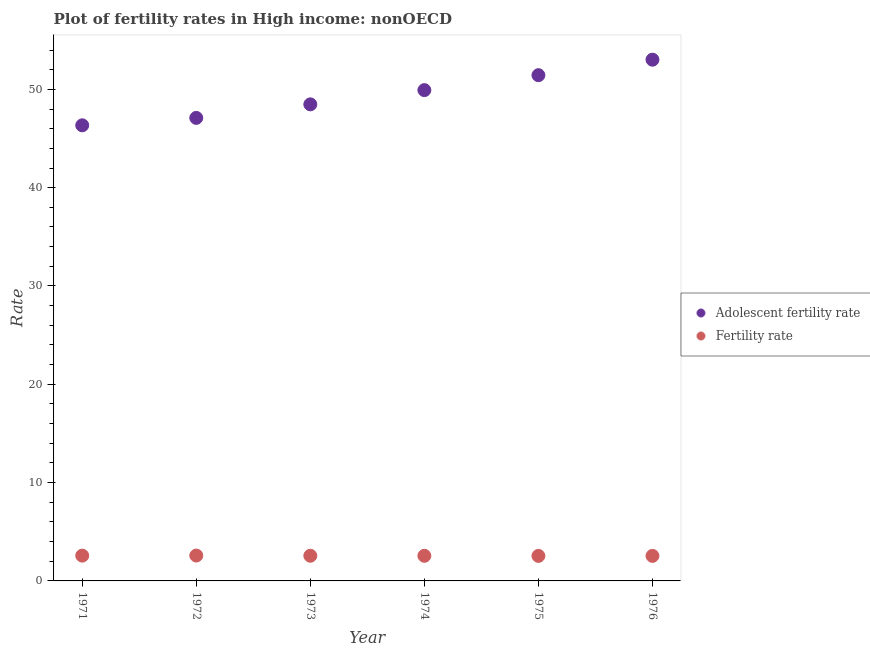What is the adolescent fertility rate in 1976?
Your answer should be compact. 53.02. Across all years, what is the maximum fertility rate?
Give a very brief answer. 2.58. Across all years, what is the minimum adolescent fertility rate?
Ensure brevity in your answer.  46.34. In which year was the adolescent fertility rate minimum?
Keep it short and to the point. 1971. What is the total fertility rate in the graph?
Give a very brief answer. 15.36. What is the difference between the fertility rate in 1972 and that in 1975?
Your response must be concise. 0.04. What is the difference between the adolescent fertility rate in 1972 and the fertility rate in 1971?
Your answer should be very brief. 44.52. What is the average fertility rate per year?
Your response must be concise. 2.56. In the year 1975, what is the difference between the adolescent fertility rate and fertility rate?
Give a very brief answer. 48.9. In how many years, is the adolescent fertility rate greater than 14?
Offer a very short reply. 6. What is the ratio of the adolescent fertility rate in 1974 to that in 1976?
Your answer should be compact. 0.94. Is the difference between the adolescent fertility rate in 1973 and 1976 greater than the difference between the fertility rate in 1973 and 1976?
Provide a short and direct response. No. What is the difference between the highest and the second highest adolescent fertility rate?
Offer a terse response. 1.58. What is the difference between the highest and the lowest adolescent fertility rate?
Your response must be concise. 6.67. Does the fertility rate monotonically increase over the years?
Ensure brevity in your answer.  No. Is the fertility rate strictly less than the adolescent fertility rate over the years?
Provide a short and direct response. Yes. What is the difference between two consecutive major ticks on the Y-axis?
Offer a very short reply. 10. Does the graph contain any zero values?
Give a very brief answer. No. Where does the legend appear in the graph?
Offer a terse response. Center right. What is the title of the graph?
Provide a succinct answer. Plot of fertility rates in High income: nonOECD. Does "Taxes on profits and capital gains" appear as one of the legend labels in the graph?
Your answer should be compact. No. What is the label or title of the X-axis?
Ensure brevity in your answer.  Year. What is the label or title of the Y-axis?
Your answer should be compact. Rate. What is the Rate in Adolescent fertility rate in 1971?
Your answer should be compact. 46.34. What is the Rate in Fertility rate in 1971?
Give a very brief answer. 2.57. What is the Rate in Adolescent fertility rate in 1972?
Keep it short and to the point. 47.1. What is the Rate of Fertility rate in 1972?
Provide a succinct answer. 2.58. What is the Rate of Adolescent fertility rate in 1973?
Your response must be concise. 48.47. What is the Rate of Fertility rate in 1973?
Your response must be concise. 2.56. What is the Rate in Adolescent fertility rate in 1974?
Give a very brief answer. 49.92. What is the Rate in Fertility rate in 1974?
Provide a short and direct response. 2.55. What is the Rate of Adolescent fertility rate in 1975?
Your answer should be very brief. 51.44. What is the Rate in Fertility rate in 1975?
Your response must be concise. 2.54. What is the Rate of Adolescent fertility rate in 1976?
Your answer should be very brief. 53.02. What is the Rate of Fertility rate in 1976?
Your answer should be compact. 2.55. Across all years, what is the maximum Rate in Adolescent fertility rate?
Make the answer very short. 53.02. Across all years, what is the maximum Rate in Fertility rate?
Keep it short and to the point. 2.58. Across all years, what is the minimum Rate in Adolescent fertility rate?
Offer a very short reply. 46.34. Across all years, what is the minimum Rate of Fertility rate?
Offer a very short reply. 2.54. What is the total Rate in Adolescent fertility rate in the graph?
Provide a short and direct response. 296.29. What is the total Rate of Fertility rate in the graph?
Your response must be concise. 15.36. What is the difference between the Rate in Adolescent fertility rate in 1971 and that in 1972?
Offer a very short reply. -0.75. What is the difference between the Rate of Fertility rate in 1971 and that in 1972?
Provide a short and direct response. -0.01. What is the difference between the Rate in Adolescent fertility rate in 1971 and that in 1973?
Keep it short and to the point. -2.13. What is the difference between the Rate of Fertility rate in 1971 and that in 1973?
Ensure brevity in your answer.  0.01. What is the difference between the Rate of Adolescent fertility rate in 1971 and that in 1974?
Offer a terse response. -3.58. What is the difference between the Rate of Fertility rate in 1971 and that in 1974?
Your response must be concise. 0.02. What is the difference between the Rate of Adolescent fertility rate in 1971 and that in 1975?
Your answer should be compact. -5.1. What is the difference between the Rate of Fertility rate in 1971 and that in 1975?
Your answer should be compact. 0.03. What is the difference between the Rate in Adolescent fertility rate in 1971 and that in 1976?
Provide a short and direct response. -6.67. What is the difference between the Rate in Fertility rate in 1971 and that in 1976?
Your response must be concise. 0.03. What is the difference between the Rate in Adolescent fertility rate in 1972 and that in 1973?
Offer a terse response. -1.38. What is the difference between the Rate in Fertility rate in 1972 and that in 1973?
Your answer should be very brief. 0.02. What is the difference between the Rate of Adolescent fertility rate in 1972 and that in 1974?
Your response must be concise. -2.83. What is the difference between the Rate in Fertility rate in 1972 and that in 1974?
Offer a terse response. 0.03. What is the difference between the Rate in Adolescent fertility rate in 1972 and that in 1975?
Your answer should be very brief. -4.35. What is the difference between the Rate in Fertility rate in 1972 and that in 1975?
Provide a succinct answer. 0.04. What is the difference between the Rate of Adolescent fertility rate in 1972 and that in 1976?
Offer a terse response. -5.92. What is the difference between the Rate in Fertility rate in 1972 and that in 1976?
Give a very brief answer. 0.03. What is the difference between the Rate of Adolescent fertility rate in 1973 and that in 1974?
Your answer should be compact. -1.45. What is the difference between the Rate in Fertility rate in 1973 and that in 1974?
Offer a very short reply. 0.01. What is the difference between the Rate in Adolescent fertility rate in 1973 and that in 1975?
Your response must be concise. -2.97. What is the difference between the Rate of Fertility rate in 1973 and that in 1975?
Your response must be concise. 0.02. What is the difference between the Rate in Adolescent fertility rate in 1973 and that in 1976?
Make the answer very short. -4.54. What is the difference between the Rate of Fertility rate in 1973 and that in 1976?
Give a very brief answer. 0.01. What is the difference between the Rate of Adolescent fertility rate in 1974 and that in 1975?
Give a very brief answer. -1.52. What is the difference between the Rate of Fertility rate in 1974 and that in 1975?
Offer a very short reply. 0.01. What is the difference between the Rate in Adolescent fertility rate in 1974 and that in 1976?
Give a very brief answer. -3.1. What is the difference between the Rate of Fertility rate in 1974 and that in 1976?
Give a very brief answer. 0.01. What is the difference between the Rate of Adolescent fertility rate in 1975 and that in 1976?
Make the answer very short. -1.58. What is the difference between the Rate in Fertility rate in 1975 and that in 1976?
Provide a succinct answer. -0. What is the difference between the Rate of Adolescent fertility rate in 1971 and the Rate of Fertility rate in 1972?
Your answer should be very brief. 43.76. What is the difference between the Rate of Adolescent fertility rate in 1971 and the Rate of Fertility rate in 1973?
Your answer should be very brief. 43.78. What is the difference between the Rate of Adolescent fertility rate in 1971 and the Rate of Fertility rate in 1974?
Your response must be concise. 43.79. What is the difference between the Rate in Adolescent fertility rate in 1971 and the Rate in Fertility rate in 1975?
Your answer should be compact. 43.8. What is the difference between the Rate of Adolescent fertility rate in 1971 and the Rate of Fertility rate in 1976?
Offer a very short reply. 43.8. What is the difference between the Rate in Adolescent fertility rate in 1972 and the Rate in Fertility rate in 1973?
Ensure brevity in your answer.  44.54. What is the difference between the Rate of Adolescent fertility rate in 1972 and the Rate of Fertility rate in 1974?
Make the answer very short. 44.54. What is the difference between the Rate of Adolescent fertility rate in 1972 and the Rate of Fertility rate in 1975?
Offer a very short reply. 44.55. What is the difference between the Rate in Adolescent fertility rate in 1972 and the Rate in Fertility rate in 1976?
Offer a terse response. 44.55. What is the difference between the Rate in Adolescent fertility rate in 1973 and the Rate in Fertility rate in 1974?
Ensure brevity in your answer.  45.92. What is the difference between the Rate of Adolescent fertility rate in 1973 and the Rate of Fertility rate in 1975?
Provide a succinct answer. 45.93. What is the difference between the Rate of Adolescent fertility rate in 1973 and the Rate of Fertility rate in 1976?
Ensure brevity in your answer.  45.93. What is the difference between the Rate in Adolescent fertility rate in 1974 and the Rate in Fertility rate in 1975?
Offer a terse response. 47.38. What is the difference between the Rate of Adolescent fertility rate in 1974 and the Rate of Fertility rate in 1976?
Your answer should be compact. 47.38. What is the difference between the Rate in Adolescent fertility rate in 1975 and the Rate in Fertility rate in 1976?
Ensure brevity in your answer.  48.9. What is the average Rate of Adolescent fertility rate per year?
Keep it short and to the point. 49.38. What is the average Rate of Fertility rate per year?
Your answer should be very brief. 2.56. In the year 1971, what is the difference between the Rate of Adolescent fertility rate and Rate of Fertility rate?
Provide a short and direct response. 43.77. In the year 1972, what is the difference between the Rate in Adolescent fertility rate and Rate in Fertility rate?
Make the answer very short. 44.52. In the year 1973, what is the difference between the Rate in Adolescent fertility rate and Rate in Fertility rate?
Keep it short and to the point. 45.91. In the year 1974, what is the difference between the Rate in Adolescent fertility rate and Rate in Fertility rate?
Offer a very short reply. 47.37. In the year 1975, what is the difference between the Rate in Adolescent fertility rate and Rate in Fertility rate?
Offer a terse response. 48.9. In the year 1976, what is the difference between the Rate of Adolescent fertility rate and Rate of Fertility rate?
Your response must be concise. 50.47. What is the ratio of the Rate in Fertility rate in 1971 to that in 1972?
Your response must be concise. 1. What is the ratio of the Rate of Adolescent fertility rate in 1971 to that in 1973?
Keep it short and to the point. 0.96. What is the ratio of the Rate in Adolescent fertility rate in 1971 to that in 1974?
Your response must be concise. 0.93. What is the ratio of the Rate of Fertility rate in 1971 to that in 1974?
Offer a very short reply. 1.01. What is the ratio of the Rate in Adolescent fertility rate in 1971 to that in 1975?
Your response must be concise. 0.9. What is the ratio of the Rate in Fertility rate in 1971 to that in 1975?
Your answer should be compact. 1.01. What is the ratio of the Rate in Adolescent fertility rate in 1971 to that in 1976?
Keep it short and to the point. 0.87. What is the ratio of the Rate in Fertility rate in 1971 to that in 1976?
Give a very brief answer. 1.01. What is the ratio of the Rate of Adolescent fertility rate in 1972 to that in 1973?
Ensure brevity in your answer.  0.97. What is the ratio of the Rate in Fertility rate in 1972 to that in 1973?
Give a very brief answer. 1.01. What is the ratio of the Rate of Adolescent fertility rate in 1972 to that in 1974?
Give a very brief answer. 0.94. What is the ratio of the Rate of Adolescent fertility rate in 1972 to that in 1975?
Ensure brevity in your answer.  0.92. What is the ratio of the Rate in Fertility rate in 1972 to that in 1975?
Offer a terse response. 1.01. What is the ratio of the Rate of Adolescent fertility rate in 1972 to that in 1976?
Offer a terse response. 0.89. What is the ratio of the Rate in Fertility rate in 1972 to that in 1976?
Offer a very short reply. 1.01. What is the ratio of the Rate in Adolescent fertility rate in 1973 to that in 1975?
Give a very brief answer. 0.94. What is the ratio of the Rate in Fertility rate in 1973 to that in 1975?
Ensure brevity in your answer.  1.01. What is the ratio of the Rate of Adolescent fertility rate in 1973 to that in 1976?
Give a very brief answer. 0.91. What is the ratio of the Rate of Adolescent fertility rate in 1974 to that in 1975?
Your answer should be compact. 0.97. What is the ratio of the Rate of Fertility rate in 1974 to that in 1975?
Offer a very short reply. 1. What is the ratio of the Rate in Adolescent fertility rate in 1974 to that in 1976?
Provide a succinct answer. 0.94. What is the ratio of the Rate of Fertility rate in 1974 to that in 1976?
Provide a short and direct response. 1. What is the ratio of the Rate in Adolescent fertility rate in 1975 to that in 1976?
Keep it short and to the point. 0.97. What is the ratio of the Rate of Fertility rate in 1975 to that in 1976?
Offer a very short reply. 1. What is the difference between the highest and the second highest Rate of Adolescent fertility rate?
Your answer should be compact. 1.58. What is the difference between the highest and the second highest Rate in Fertility rate?
Your response must be concise. 0.01. What is the difference between the highest and the lowest Rate in Adolescent fertility rate?
Your response must be concise. 6.67. What is the difference between the highest and the lowest Rate of Fertility rate?
Give a very brief answer. 0.04. 